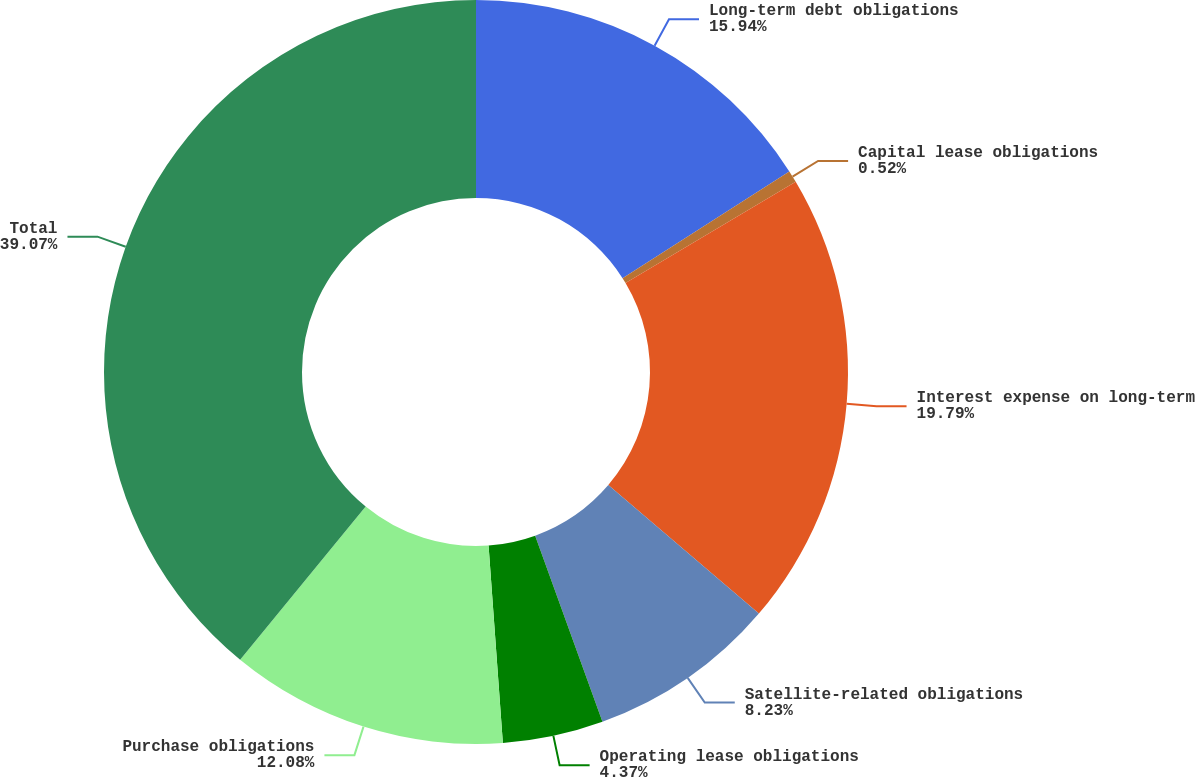Convert chart. <chart><loc_0><loc_0><loc_500><loc_500><pie_chart><fcel>Long-term debt obligations<fcel>Capital lease obligations<fcel>Interest expense on long-term<fcel>Satellite-related obligations<fcel>Operating lease obligations<fcel>Purchase obligations<fcel>Total<nl><fcel>15.94%<fcel>0.52%<fcel>19.79%<fcel>8.23%<fcel>4.37%<fcel>12.08%<fcel>39.07%<nl></chart> 